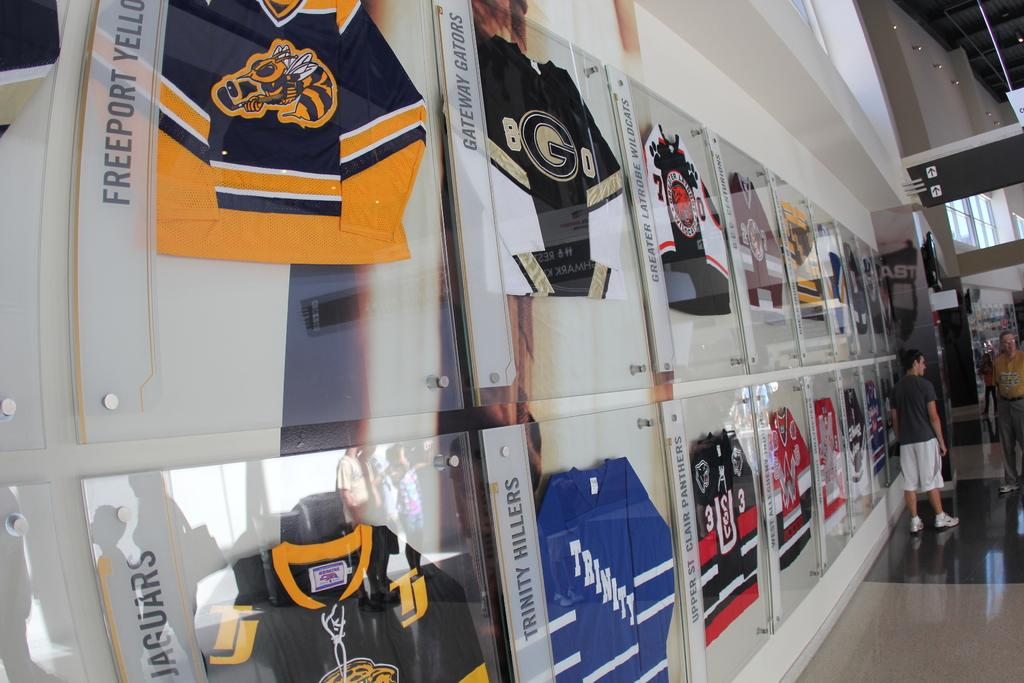<image>
Give a short and clear explanation of the subsequent image. A display of various jerseys including one for the Jaguars 